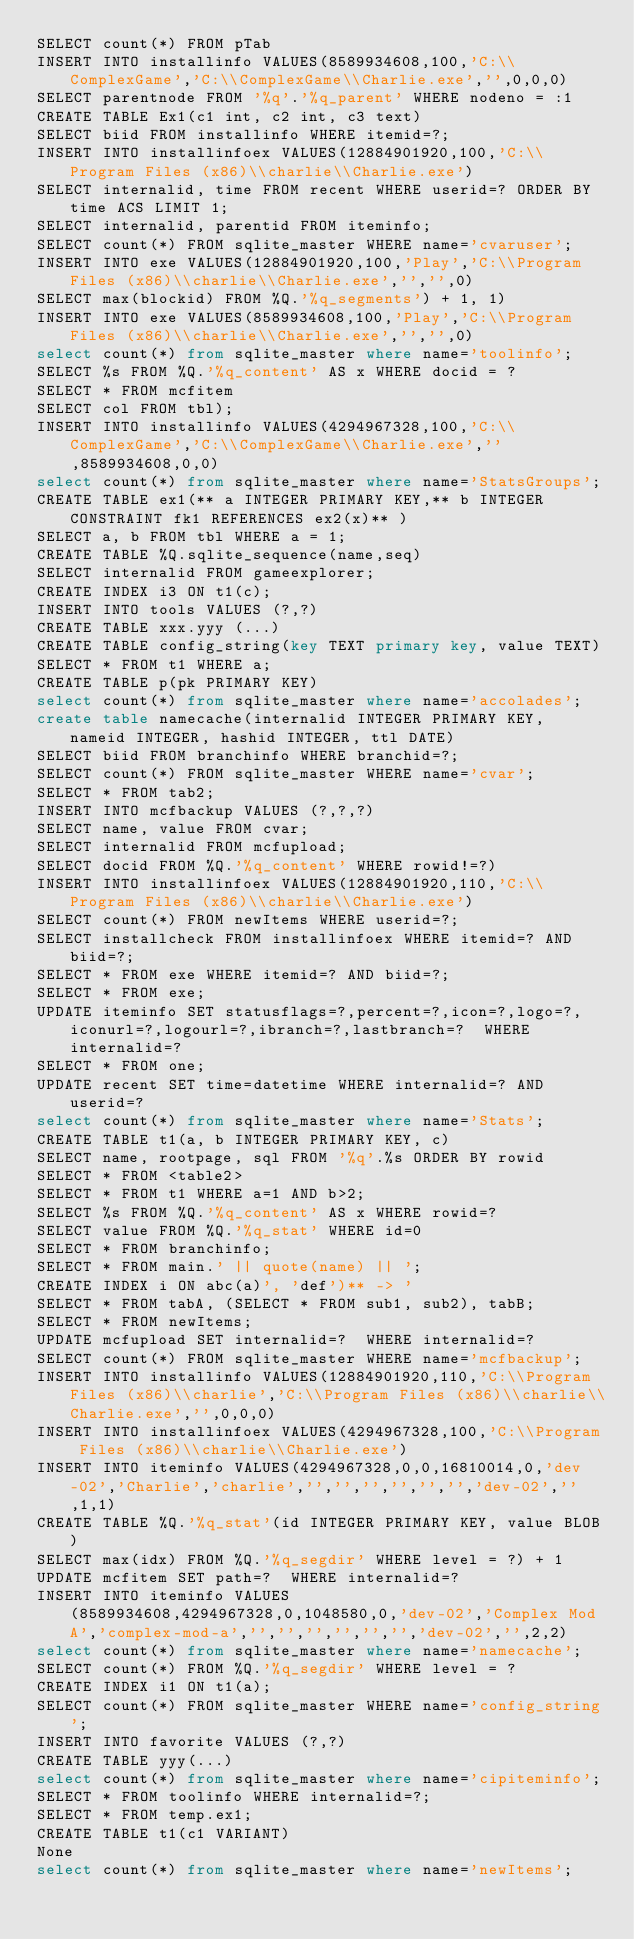Convert code to text. <code><loc_0><loc_0><loc_500><loc_500><_SQL_>SELECT count(*) FROM pTab
INSERT INTO installinfo VALUES(8589934608,100,'C:\\ComplexGame','C:\\ComplexGame\\Charlie.exe','',0,0,0)
SELECT parentnode FROM '%q'.'%q_parent' WHERE nodeno = :1
CREATE TABLE Ex1(c1 int, c2 int, c3 text)
SELECT biid FROM installinfo WHERE itemid=?;
INSERT INTO installinfoex VALUES(12884901920,100,'C:\\Program Files (x86)\\charlie\\Charlie.exe')
SELECT internalid, time FROM recent WHERE userid=? ORDER BY time ACS LIMIT 1;
SELECT internalid, parentid FROM iteminfo;
SELECT count(*) FROM sqlite_master WHERE name='cvaruser';
INSERT INTO exe VALUES(12884901920,100,'Play','C:\\Program Files (x86)\\charlie\\Charlie.exe','','',0)
SELECT max(blockid) FROM %Q.'%q_segments') + 1, 1)
INSERT INTO exe VALUES(8589934608,100,'Play','C:\\Program Files (x86)\\charlie\\Charlie.exe','','',0)
select count(*) from sqlite_master where name='toolinfo';
SELECT %s FROM %Q.'%q_content' AS x WHERE docid = ?
SELECT * FROM mcfitem
SELECT col FROM tbl);
INSERT INTO installinfo VALUES(4294967328,100,'C:\\ComplexGame','C:\\ComplexGame\\Charlie.exe','',8589934608,0,0)
select count(*) from sqlite_master where name='StatsGroups';
CREATE TABLE ex1(** a INTEGER PRIMARY KEY,** b INTEGER CONSTRAINT fk1 REFERENCES ex2(x)** )
SELECT a, b FROM tbl WHERE a = 1;
CREATE TABLE %Q.sqlite_sequence(name,seq)
SELECT internalid FROM gameexplorer;
CREATE INDEX i3 ON t1(c);
INSERT INTO tools VALUES (?,?)
CREATE TABLE xxx.yyy (...)
CREATE TABLE config_string(key TEXT primary key, value TEXT)
SELECT * FROM t1 WHERE a;
CREATE TABLE p(pk PRIMARY KEY)
select count(*) from sqlite_master where name='accolades';
create table namecache(internalid INTEGER PRIMARY KEY, nameid INTEGER, hashid INTEGER, ttl DATE)
SELECT biid FROM branchinfo WHERE branchid=?;
SELECT count(*) FROM sqlite_master WHERE name='cvar';
SELECT * FROM tab2;
INSERT INTO mcfbackup VALUES (?,?,?)
SELECT name, value FROM cvar;
SELECT internalid FROM mcfupload;
SELECT docid FROM %Q.'%q_content' WHERE rowid!=?)
INSERT INTO installinfoex VALUES(12884901920,110,'C:\\Program Files (x86)\\charlie\\Charlie.exe')
SELECT count(*) FROM newItems WHERE userid=?;
SELECT installcheck FROM installinfoex WHERE itemid=? AND biid=?;
SELECT * FROM exe WHERE itemid=? AND biid=?;
SELECT * FROM exe;
UPDATE iteminfo SET statusflags=?,percent=?,icon=?,logo=?,iconurl=?,logourl=?,ibranch=?,lastbranch=?  WHERE internalid=?
SELECT * FROM one;
UPDATE recent SET time=datetime WHERE internalid=? AND userid=? 
select count(*) from sqlite_master where name='Stats';
CREATE TABLE t1(a, b INTEGER PRIMARY KEY, c)
SELECT name, rootpage, sql FROM '%q'.%s ORDER BY rowid
SELECT * FROM <table2>
SELECT * FROM t1 WHERE a=1 AND b>2;
SELECT %s FROM %Q.'%q_content' AS x WHERE rowid=?
SELECT value FROM %Q.'%q_stat' WHERE id=0
SELECT * FROM branchinfo;
SELECT * FROM main.' || quote(name) || ';
CREATE INDEX i ON abc(a)', 'def')** -> '
SELECT * FROM tabA, (SELECT * FROM sub1, sub2), tabB;
SELECT * FROM newItems;
UPDATE mcfupload SET internalid=?  WHERE internalid=?
SELECT count(*) FROM sqlite_master WHERE name='mcfbackup';
INSERT INTO installinfo VALUES(12884901920,110,'C:\\Program Files (x86)\\charlie','C:\\Program Files (x86)\\charlie\\Charlie.exe','',0,0,0)
INSERT INTO installinfoex VALUES(4294967328,100,'C:\\Program Files (x86)\\charlie\\Charlie.exe')
INSERT INTO iteminfo VALUES(4294967328,0,0,16810014,0,'dev-02','Charlie','charlie','','','','','','','dev-02','',1,1)
CREATE TABLE %Q.'%q_stat'(id INTEGER PRIMARY KEY, value BLOB)
SELECT max(idx) FROM %Q.'%q_segdir' WHERE level = ?) + 1
UPDATE mcfitem SET path=?  WHERE internalid=?
INSERT INTO iteminfo VALUES(8589934608,4294967328,0,1048580,0,'dev-02','Complex Mod A','complex-mod-a','','','','','','','dev-02','',2,2)
select count(*) from sqlite_master where name='namecache';
SELECT count(*) FROM %Q.'%q_segdir' WHERE level = ?
CREATE INDEX i1 ON t1(a);
SELECT count(*) FROM sqlite_master WHERE name='config_string';
INSERT INTO favorite VALUES (?,?)
CREATE TABLE yyy(...)
select count(*) from sqlite_master where name='cipiteminfo';
SELECT * FROM toolinfo WHERE internalid=?;
SELECT * FROM temp.ex1;
CREATE TABLE t1(c1 VARIANT)
None
select count(*) from sqlite_master where name='newItems';</code> 